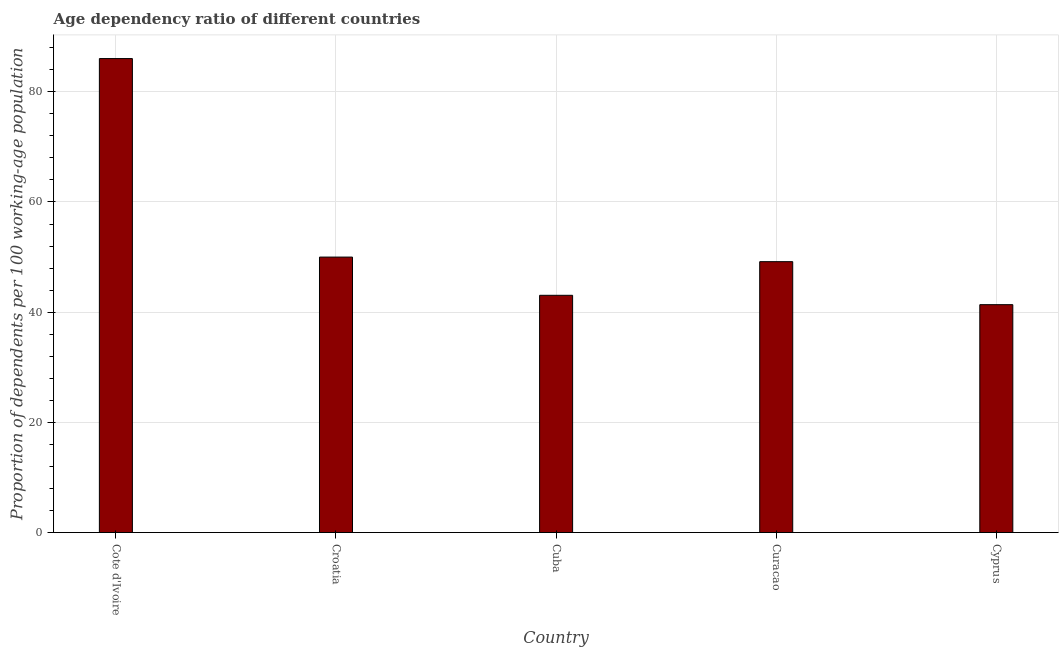Does the graph contain any zero values?
Keep it short and to the point. No. Does the graph contain grids?
Keep it short and to the point. Yes. What is the title of the graph?
Give a very brief answer. Age dependency ratio of different countries. What is the label or title of the Y-axis?
Give a very brief answer. Proportion of dependents per 100 working-age population. What is the age dependency ratio in Croatia?
Provide a succinct answer. 50. Across all countries, what is the maximum age dependency ratio?
Give a very brief answer. 86.02. Across all countries, what is the minimum age dependency ratio?
Give a very brief answer. 41.36. In which country was the age dependency ratio maximum?
Provide a short and direct response. Cote d'Ivoire. In which country was the age dependency ratio minimum?
Offer a terse response. Cyprus. What is the sum of the age dependency ratio?
Give a very brief answer. 269.6. What is the difference between the age dependency ratio in Cote d'Ivoire and Croatia?
Make the answer very short. 36.02. What is the average age dependency ratio per country?
Ensure brevity in your answer.  53.92. What is the median age dependency ratio?
Give a very brief answer. 49.16. In how many countries, is the age dependency ratio greater than 56 ?
Ensure brevity in your answer.  1. What is the ratio of the age dependency ratio in Curacao to that in Cyprus?
Your answer should be compact. 1.19. Is the age dependency ratio in Cote d'Ivoire less than that in Curacao?
Offer a very short reply. No. What is the difference between the highest and the second highest age dependency ratio?
Offer a very short reply. 36.02. Is the sum of the age dependency ratio in Croatia and Cyprus greater than the maximum age dependency ratio across all countries?
Provide a succinct answer. Yes. What is the difference between the highest and the lowest age dependency ratio?
Make the answer very short. 44.66. How many bars are there?
Offer a terse response. 5. Are all the bars in the graph horizontal?
Your answer should be compact. No. How many countries are there in the graph?
Keep it short and to the point. 5. What is the difference between two consecutive major ticks on the Y-axis?
Your response must be concise. 20. Are the values on the major ticks of Y-axis written in scientific E-notation?
Provide a succinct answer. No. What is the Proportion of dependents per 100 working-age population of Cote d'Ivoire?
Make the answer very short. 86.02. What is the Proportion of dependents per 100 working-age population of Croatia?
Give a very brief answer. 50. What is the Proportion of dependents per 100 working-age population in Cuba?
Your answer should be very brief. 43.06. What is the Proportion of dependents per 100 working-age population in Curacao?
Keep it short and to the point. 49.16. What is the Proportion of dependents per 100 working-age population in Cyprus?
Your response must be concise. 41.36. What is the difference between the Proportion of dependents per 100 working-age population in Cote d'Ivoire and Croatia?
Your answer should be compact. 36.02. What is the difference between the Proportion of dependents per 100 working-age population in Cote d'Ivoire and Cuba?
Make the answer very short. 42.96. What is the difference between the Proportion of dependents per 100 working-age population in Cote d'Ivoire and Curacao?
Offer a very short reply. 36.86. What is the difference between the Proportion of dependents per 100 working-age population in Cote d'Ivoire and Cyprus?
Give a very brief answer. 44.66. What is the difference between the Proportion of dependents per 100 working-age population in Croatia and Cuba?
Keep it short and to the point. 6.94. What is the difference between the Proportion of dependents per 100 working-age population in Croatia and Curacao?
Provide a succinct answer. 0.83. What is the difference between the Proportion of dependents per 100 working-age population in Croatia and Cyprus?
Keep it short and to the point. 8.64. What is the difference between the Proportion of dependents per 100 working-age population in Cuba and Curacao?
Offer a terse response. -6.11. What is the difference between the Proportion of dependents per 100 working-age population in Cuba and Cyprus?
Offer a terse response. 1.7. What is the difference between the Proportion of dependents per 100 working-age population in Curacao and Cyprus?
Provide a succinct answer. 7.8. What is the ratio of the Proportion of dependents per 100 working-age population in Cote d'Ivoire to that in Croatia?
Offer a very short reply. 1.72. What is the ratio of the Proportion of dependents per 100 working-age population in Cote d'Ivoire to that in Cuba?
Keep it short and to the point. 2. What is the ratio of the Proportion of dependents per 100 working-age population in Cote d'Ivoire to that in Curacao?
Provide a short and direct response. 1.75. What is the ratio of the Proportion of dependents per 100 working-age population in Cote d'Ivoire to that in Cyprus?
Ensure brevity in your answer.  2.08. What is the ratio of the Proportion of dependents per 100 working-age population in Croatia to that in Cuba?
Offer a very short reply. 1.16. What is the ratio of the Proportion of dependents per 100 working-age population in Croatia to that in Curacao?
Provide a short and direct response. 1.02. What is the ratio of the Proportion of dependents per 100 working-age population in Croatia to that in Cyprus?
Offer a terse response. 1.21. What is the ratio of the Proportion of dependents per 100 working-age population in Cuba to that in Curacao?
Provide a short and direct response. 0.88. What is the ratio of the Proportion of dependents per 100 working-age population in Cuba to that in Cyprus?
Provide a short and direct response. 1.04. What is the ratio of the Proportion of dependents per 100 working-age population in Curacao to that in Cyprus?
Give a very brief answer. 1.19. 